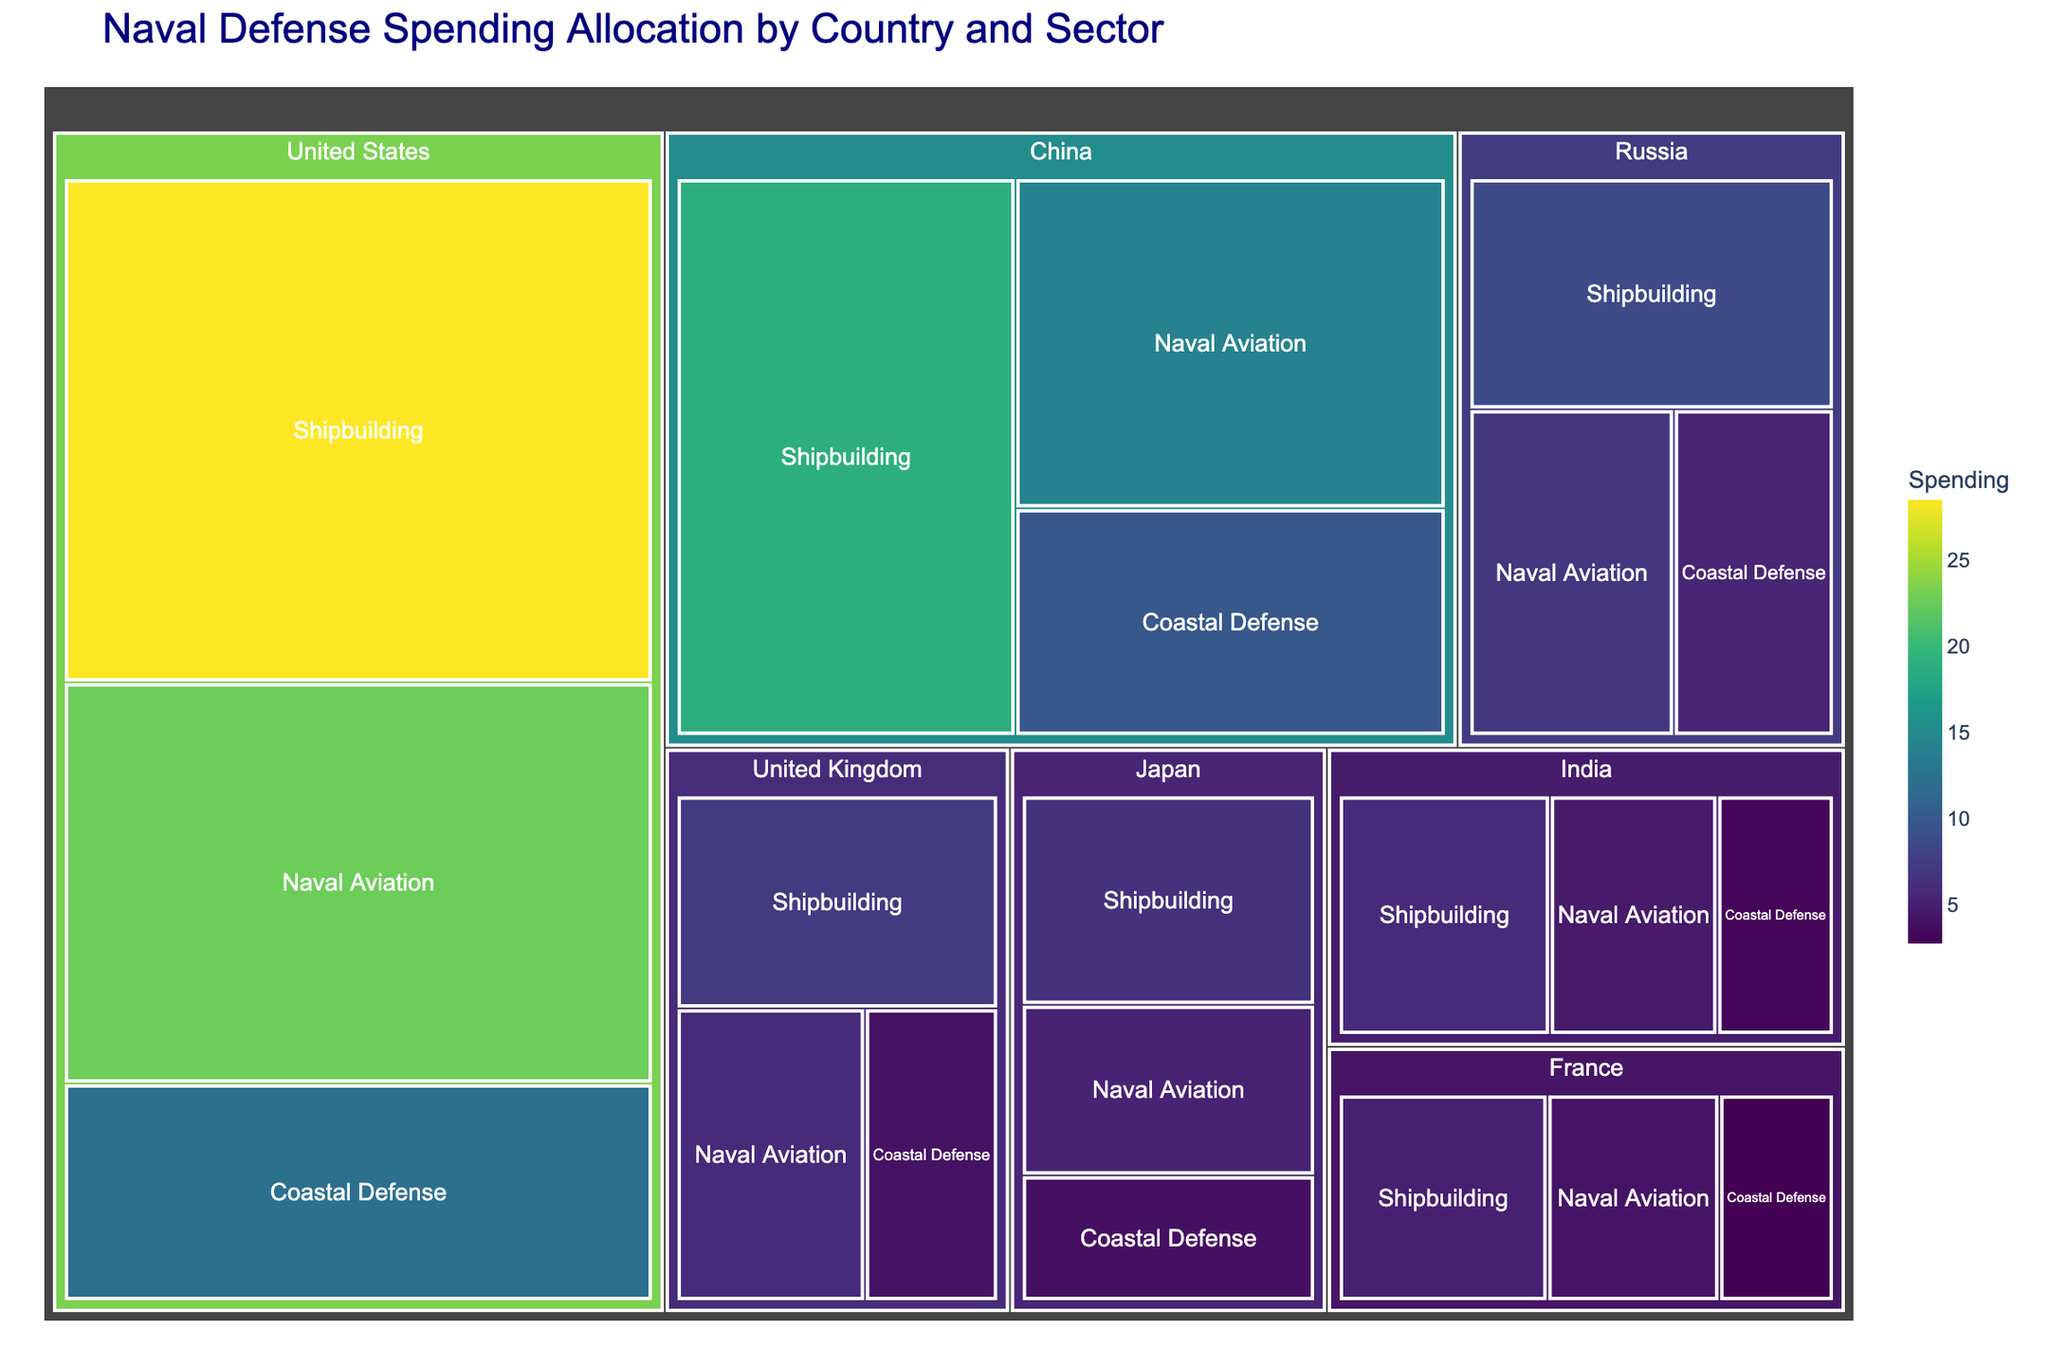how much does the United States spend on Coastal Defense? Look for the sector labeled "Coastal Defense" under the "United States" category in the treemap. The spending value is shown inside the corresponding box.
Answer: $12.3B which country spends the most on Shipbuilding? Compare the Shipbuilding spending values for each country in the treemap. Find the country with the highest value.
Answer: United States what is the total spending on Naval Aviation by Russia and Japan combined? Find the spending values for Naval Aviation for both Russia and Japan in the treemap. Add them together: 6.9 (Russia) + 5.3 (Japan).
Answer: $12.2B which country has the lowest spending in any sector? For each country in the treemap, find the lowest spending value among all sectors. Determine which country has the lowest overall amount.
Answer: France (Coastal Defense) how does China's spending on Coastal Defense compare to India's? Look at the Coastal Defense spending values for China and India in the treemap and compare them. China spends 9.8 and India spends 3.2.
Answer: China's spending is higher Which sector in the United Kingdom has the highest allocation? Identify the sector in the United Kingdom part of the treemap with the largest spending value. Compare the three sectors: Shipbuilding, Coastal Defense, and Naval Aviation.
Answer: Shipbuilding How much more does the United States spend on Shipbuilding compared to France? Locate the Shipbuilding spending for both the United States and France in the treemap. Subtract France's spending from the United States' spending: 28.5 - 5.1.
Answer: $23.4B what is the average spending on Shipbuilding across all listed countries? Sum up the Shipbuilding spending values for all countries and divide by the number of countries: (28.5 + 18.9 + 8.7 + 7.2 + 6.5 + 5.8 + 5.1) / 7.
Answer: $11.5B Ranking by Coastal Defense spending, which country is third highest? Arrange the Coastal Defense spending values for all countries in descending order. Identify the third highest value among them: United States (12.3), China (9.8), Russia (5.4), United Kingdom (4.1), Japan (3.9), India (3.2), France (2.8).
Answer: Russia 